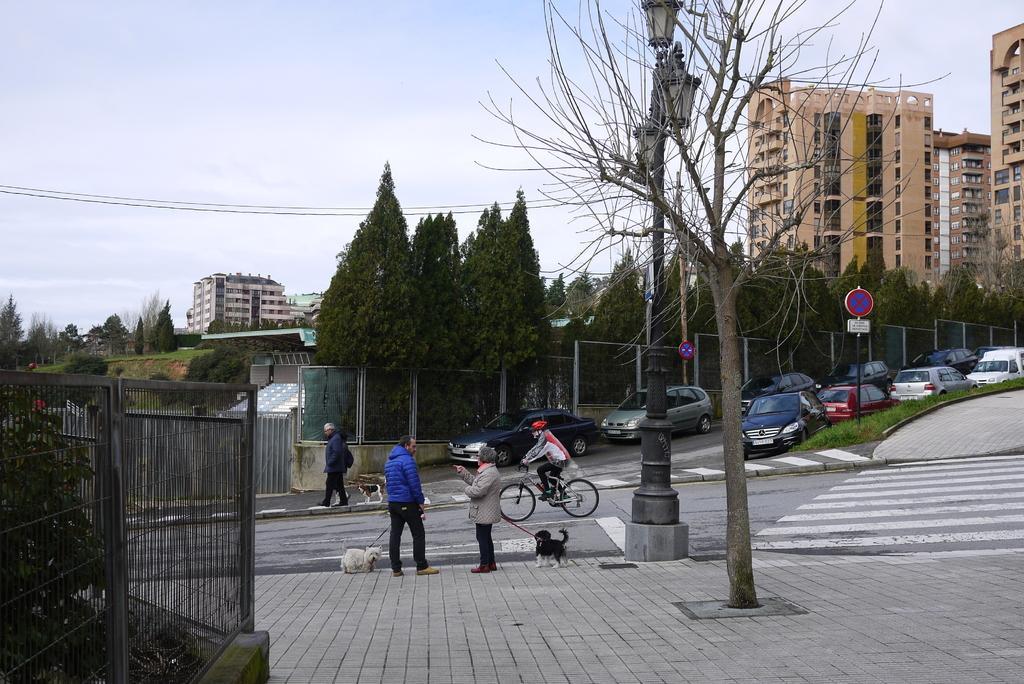In one or two sentences, can you explain what this image depicts? This is a picture of the outside of a city, in this picture in the center there are two persons who are standing and talking. And they are holding dogs and one person is walking on a footpath, and one person is sitting on a cycle and riding. On the right side there are some buildings, and in the center there are trees, fence and vehicles. At the bottom there is a walkway, on the left side there are some trees and a fence. In the background there are some buildings, on the top of the image there are some wires and sky. 